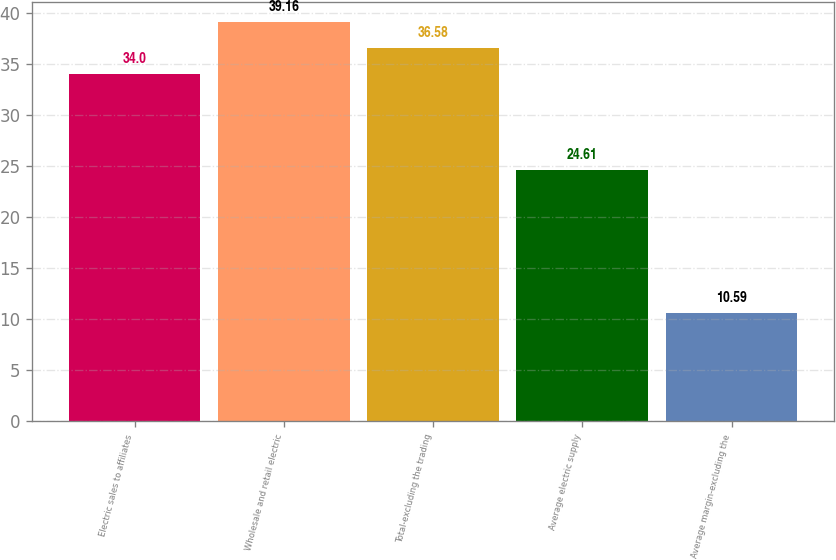Convert chart to OTSL. <chart><loc_0><loc_0><loc_500><loc_500><bar_chart><fcel>Electric sales to affiliates<fcel>Wholesale and retail electric<fcel>Total-excluding the trading<fcel>Average electric supply<fcel>Average margin-excluding the<nl><fcel>34<fcel>39.16<fcel>36.58<fcel>24.61<fcel>10.59<nl></chart> 